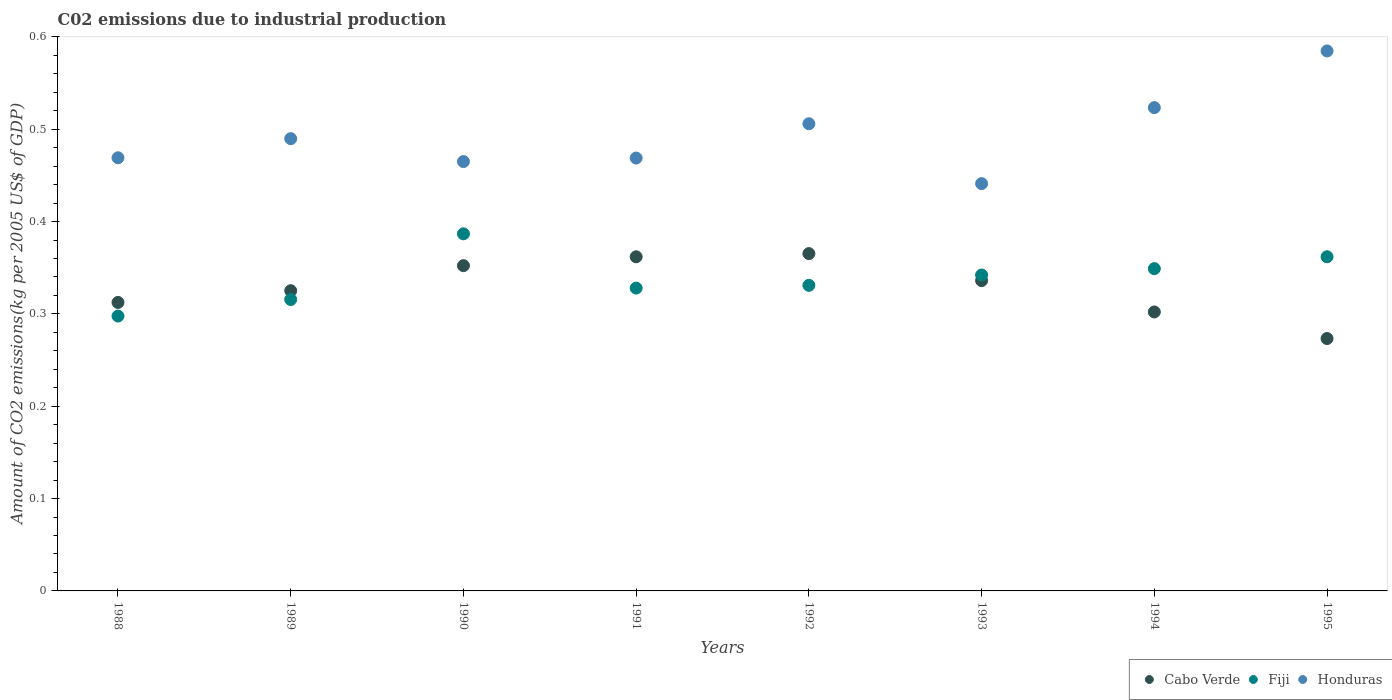What is the amount of CO2 emitted due to industrial production in Fiji in 1988?
Offer a very short reply. 0.3. Across all years, what is the maximum amount of CO2 emitted due to industrial production in Honduras?
Provide a succinct answer. 0.58. Across all years, what is the minimum amount of CO2 emitted due to industrial production in Cabo Verde?
Provide a short and direct response. 0.27. In which year was the amount of CO2 emitted due to industrial production in Honduras maximum?
Offer a very short reply. 1995. In which year was the amount of CO2 emitted due to industrial production in Fiji minimum?
Offer a terse response. 1988. What is the total amount of CO2 emitted due to industrial production in Fiji in the graph?
Your answer should be compact. 2.71. What is the difference between the amount of CO2 emitted due to industrial production in Cabo Verde in 1990 and that in 1993?
Offer a terse response. 0.02. What is the difference between the amount of CO2 emitted due to industrial production in Fiji in 1994 and the amount of CO2 emitted due to industrial production in Honduras in 1989?
Ensure brevity in your answer.  -0.14. What is the average amount of CO2 emitted due to industrial production in Cabo Verde per year?
Ensure brevity in your answer.  0.33. In the year 1994, what is the difference between the amount of CO2 emitted due to industrial production in Cabo Verde and amount of CO2 emitted due to industrial production in Honduras?
Give a very brief answer. -0.22. What is the ratio of the amount of CO2 emitted due to industrial production in Cabo Verde in 1988 to that in 1992?
Ensure brevity in your answer.  0.86. Is the difference between the amount of CO2 emitted due to industrial production in Cabo Verde in 1990 and 1991 greater than the difference between the amount of CO2 emitted due to industrial production in Honduras in 1990 and 1991?
Your response must be concise. No. What is the difference between the highest and the second highest amount of CO2 emitted due to industrial production in Cabo Verde?
Ensure brevity in your answer.  0. What is the difference between the highest and the lowest amount of CO2 emitted due to industrial production in Honduras?
Your answer should be compact. 0.14. In how many years, is the amount of CO2 emitted due to industrial production in Cabo Verde greater than the average amount of CO2 emitted due to industrial production in Cabo Verde taken over all years?
Your response must be concise. 4. Is the sum of the amount of CO2 emitted due to industrial production in Honduras in 1990 and 1991 greater than the maximum amount of CO2 emitted due to industrial production in Cabo Verde across all years?
Your response must be concise. Yes. Is it the case that in every year, the sum of the amount of CO2 emitted due to industrial production in Cabo Verde and amount of CO2 emitted due to industrial production in Fiji  is greater than the amount of CO2 emitted due to industrial production in Honduras?
Provide a succinct answer. Yes. Does the amount of CO2 emitted due to industrial production in Cabo Verde monotonically increase over the years?
Offer a very short reply. No. Is the amount of CO2 emitted due to industrial production in Fiji strictly greater than the amount of CO2 emitted due to industrial production in Cabo Verde over the years?
Offer a very short reply. No. Is the amount of CO2 emitted due to industrial production in Honduras strictly less than the amount of CO2 emitted due to industrial production in Cabo Verde over the years?
Provide a short and direct response. No. How many dotlines are there?
Your answer should be very brief. 3. How many years are there in the graph?
Your answer should be compact. 8. What is the difference between two consecutive major ticks on the Y-axis?
Give a very brief answer. 0.1. Are the values on the major ticks of Y-axis written in scientific E-notation?
Make the answer very short. No. Does the graph contain any zero values?
Offer a terse response. No. Where does the legend appear in the graph?
Give a very brief answer. Bottom right. How many legend labels are there?
Make the answer very short. 3. How are the legend labels stacked?
Provide a short and direct response. Horizontal. What is the title of the graph?
Offer a very short reply. C02 emissions due to industrial production. Does "Senegal" appear as one of the legend labels in the graph?
Make the answer very short. No. What is the label or title of the X-axis?
Provide a short and direct response. Years. What is the label or title of the Y-axis?
Provide a short and direct response. Amount of CO2 emissions(kg per 2005 US$ of GDP). What is the Amount of CO2 emissions(kg per 2005 US$ of GDP) of Cabo Verde in 1988?
Make the answer very short. 0.31. What is the Amount of CO2 emissions(kg per 2005 US$ of GDP) in Fiji in 1988?
Make the answer very short. 0.3. What is the Amount of CO2 emissions(kg per 2005 US$ of GDP) in Honduras in 1988?
Your answer should be very brief. 0.47. What is the Amount of CO2 emissions(kg per 2005 US$ of GDP) in Cabo Verde in 1989?
Keep it short and to the point. 0.33. What is the Amount of CO2 emissions(kg per 2005 US$ of GDP) in Fiji in 1989?
Give a very brief answer. 0.32. What is the Amount of CO2 emissions(kg per 2005 US$ of GDP) of Honduras in 1989?
Your answer should be very brief. 0.49. What is the Amount of CO2 emissions(kg per 2005 US$ of GDP) of Cabo Verde in 1990?
Offer a terse response. 0.35. What is the Amount of CO2 emissions(kg per 2005 US$ of GDP) of Fiji in 1990?
Keep it short and to the point. 0.39. What is the Amount of CO2 emissions(kg per 2005 US$ of GDP) of Honduras in 1990?
Offer a terse response. 0.46. What is the Amount of CO2 emissions(kg per 2005 US$ of GDP) of Cabo Verde in 1991?
Your answer should be compact. 0.36. What is the Amount of CO2 emissions(kg per 2005 US$ of GDP) in Fiji in 1991?
Make the answer very short. 0.33. What is the Amount of CO2 emissions(kg per 2005 US$ of GDP) in Honduras in 1991?
Your answer should be compact. 0.47. What is the Amount of CO2 emissions(kg per 2005 US$ of GDP) in Cabo Verde in 1992?
Keep it short and to the point. 0.37. What is the Amount of CO2 emissions(kg per 2005 US$ of GDP) of Fiji in 1992?
Provide a succinct answer. 0.33. What is the Amount of CO2 emissions(kg per 2005 US$ of GDP) in Honduras in 1992?
Your answer should be compact. 0.51. What is the Amount of CO2 emissions(kg per 2005 US$ of GDP) of Cabo Verde in 1993?
Provide a succinct answer. 0.34. What is the Amount of CO2 emissions(kg per 2005 US$ of GDP) of Fiji in 1993?
Ensure brevity in your answer.  0.34. What is the Amount of CO2 emissions(kg per 2005 US$ of GDP) of Honduras in 1993?
Ensure brevity in your answer.  0.44. What is the Amount of CO2 emissions(kg per 2005 US$ of GDP) of Cabo Verde in 1994?
Your answer should be very brief. 0.3. What is the Amount of CO2 emissions(kg per 2005 US$ of GDP) in Fiji in 1994?
Your answer should be very brief. 0.35. What is the Amount of CO2 emissions(kg per 2005 US$ of GDP) of Honduras in 1994?
Provide a succinct answer. 0.52. What is the Amount of CO2 emissions(kg per 2005 US$ of GDP) in Cabo Verde in 1995?
Ensure brevity in your answer.  0.27. What is the Amount of CO2 emissions(kg per 2005 US$ of GDP) of Fiji in 1995?
Provide a succinct answer. 0.36. What is the Amount of CO2 emissions(kg per 2005 US$ of GDP) of Honduras in 1995?
Provide a short and direct response. 0.58. Across all years, what is the maximum Amount of CO2 emissions(kg per 2005 US$ of GDP) in Cabo Verde?
Keep it short and to the point. 0.37. Across all years, what is the maximum Amount of CO2 emissions(kg per 2005 US$ of GDP) in Fiji?
Your answer should be compact. 0.39. Across all years, what is the maximum Amount of CO2 emissions(kg per 2005 US$ of GDP) of Honduras?
Make the answer very short. 0.58. Across all years, what is the minimum Amount of CO2 emissions(kg per 2005 US$ of GDP) of Cabo Verde?
Your response must be concise. 0.27. Across all years, what is the minimum Amount of CO2 emissions(kg per 2005 US$ of GDP) in Fiji?
Your response must be concise. 0.3. Across all years, what is the minimum Amount of CO2 emissions(kg per 2005 US$ of GDP) of Honduras?
Offer a very short reply. 0.44. What is the total Amount of CO2 emissions(kg per 2005 US$ of GDP) in Cabo Verde in the graph?
Give a very brief answer. 2.63. What is the total Amount of CO2 emissions(kg per 2005 US$ of GDP) in Fiji in the graph?
Make the answer very short. 2.71. What is the total Amount of CO2 emissions(kg per 2005 US$ of GDP) in Honduras in the graph?
Provide a succinct answer. 3.95. What is the difference between the Amount of CO2 emissions(kg per 2005 US$ of GDP) in Cabo Verde in 1988 and that in 1989?
Your answer should be compact. -0.01. What is the difference between the Amount of CO2 emissions(kg per 2005 US$ of GDP) in Fiji in 1988 and that in 1989?
Offer a very short reply. -0.02. What is the difference between the Amount of CO2 emissions(kg per 2005 US$ of GDP) in Honduras in 1988 and that in 1989?
Offer a very short reply. -0.02. What is the difference between the Amount of CO2 emissions(kg per 2005 US$ of GDP) of Cabo Verde in 1988 and that in 1990?
Offer a very short reply. -0.04. What is the difference between the Amount of CO2 emissions(kg per 2005 US$ of GDP) in Fiji in 1988 and that in 1990?
Offer a very short reply. -0.09. What is the difference between the Amount of CO2 emissions(kg per 2005 US$ of GDP) in Honduras in 1988 and that in 1990?
Give a very brief answer. 0. What is the difference between the Amount of CO2 emissions(kg per 2005 US$ of GDP) of Cabo Verde in 1988 and that in 1991?
Provide a succinct answer. -0.05. What is the difference between the Amount of CO2 emissions(kg per 2005 US$ of GDP) in Fiji in 1988 and that in 1991?
Your answer should be very brief. -0.03. What is the difference between the Amount of CO2 emissions(kg per 2005 US$ of GDP) of Honduras in 1988 and that in 1991?
Your answer should be compact. 0. What is the difference between the Amount of CO2 emissions(kg per 2005 US$ of GDP) in Cabo Verde in 1988 and that in 1992?
Ensure brevity in your answer.  -0.05. What is the difference between the Amount of CO2 emissions(kg per 2005 US$ of GDP) of Fiji in 1988 and that in 1992?
Provide a succinct answer. -0.03. What is the difference between the Amount of CO2 emissions(kg per 2005 US$ of GDP) in Honduras in 1988 and that in 1992?
Provide a succinct answer. -0.04. What is the difference between the Amount of CO2 emissions(kg per 2005 US$ of GDP) of Cabo Verde in 1988 and that in 1993?
Offer a terse response. -0.02. What is the difference between the Amount of CO2 emissions(kg per 2005 US$ of GDP) of Fiji in 1988 and that in 1993?
Your answer should be very brief. -0.04. What is the difference between the Amount of CO2 emissions(kg per 2005 US$ of GDP) in Honduras in 1988 and that in 1993?
Your answer should be very brief. 0.03. What is the difference between the Amount of CO2 emissions(kg per 2005 US$ of GDP) of Cabo Verde in 1988 and that in 1994?
Provide a succinct answer. 0.01. What is the difference between the Amount of CO2 emissions(kg per 2005 US$ of GDP) of Fiji in 1988 and that in 1994?
Your response must be concise. -0.05. What is the difference between the Amount of CO2 emissions(kg per 2005 US$ of GDP) in Honduras in 1988 and that in 1994?
Make the answer very short. -0.05. What is the difference between the Amount of CO2 emissions(kg per 2005 US$ of GDP) of Cabo Verde in 1988 and that in 1995?
Your answer should be very brief. 0.04. What is the difference between the Amount of CO2 emissions(kg per 2005 US$ of GDP) of Fiji in 1988 and that in 1995?
Your response must be concise. -0.06. What is the difference between the Amount of CO2 emissions(kg per 2005 US$ of GDP) of Honduras in 1988 and that in 1995?
Provide a succinct answer. -0.12. What is the difference between the Amount of CO2 emissions(kg per 2005 US$ of GDP) in Cabo Verde in 1989 and that in 1990?
Keep it short and to the point. -0.03. What is the difference between the Amount of CO2 emissions(kg per 2005 US$ of GDP) in Fiji in 1989 and that in 1990?
Ensure brevity in your answer.  -0.07. What is the difference between the Amount of CO2 emissions(kg per 2005 US$ of GDP) in Honduras in 1989 and that in 1990?
Provide a short and direct response. 0.02. What is the difference between the Amount of CO2 emissions(kg per 2005 US$ of GDP) in Cabo Verde in 1989 and that in 1991?
Your answer should be very brief. -0.04. What is the difference between the Amount of CO2 emissions(kg per 2005 US$ of GDP) in Fiji in 1989 and that in 1991?
Ensure brevity in your answer.  -0.01. What is the difference between the Amount of CO2 emissions(kg per 2005 US$ of GDP) of Honduras in 1989 and that in 1991?
Offer a very short reply. 0.02. What is the difference between the Amount of CO2 emissions(kg per 2005 US$ of GDP) in Cabo Verde in 1989 and that in 1992?
Your answer should be very brief. -0.04. What is the difference between the Amount of CO2 emissions(kg per 2005 US$ of GDP) in Fiji in 1989 and that in 1992?
Make the answer very short. -0.02. What is the difference between the Amount of CO2 emissions(kg per 2005 US$ of GDP) of Honduras in 1989 and that in 1992?
Make the answer very short. -0.02. What is the difference between the Amount of CO2 emissions(kg per 2005 US$ of GDP) in Cabo Verde in 1989 and that in 1993?
Give a very brief answer. -0.01. What is the difference between the Amount of CO2 emissions(kg per 2005 US$ of GDP) in Fiji in 1989 and that in 1993?
Offer a very short reply. -0.03. What is the difference between the Amount of CO2 emissions(kg per 2005 US$ of GDP) in Honduras in 1989 and that in 1993?
Your answer should be very brief. 0.05. What is the difference between the Amount of CO2 emissions(kg per 2005 US$ of GDP) in Cabo Verde in 1989 and that in 1994?
Your response must be concise. 0.02. What is the difference between the Amount of CO2 emissions(kg per 2005 US$ of GDP) in Fiji in 1989 and that in 1994?
Your answer should be compact. -0.03. What is the difference between the Amount of CO2 emissions(kg per 2005 US$ of GDP) in Honduras in 1989 and that in 1994?
Your response must be concise. -0.03. What is the difference between the Amount of CO2 emissions(kg per 2005 US$ of GDP) in Cabo Verde in 1989 and that in 1995?
Make the answer very short. 0.05. What is the difference between the Amount of CO2 emissions(kg per 2005 US$ of GDP) of Fiji in 1989 and that in 1995?
Make the answer very short. -0.05. What is the difference between the Amount of CO2 emissions(kg per 2005 US$ of GDP) in Honduras in 1989 and that in 1995?
Offer a very short reply. -0.1. What is the difference between the Amount of CO2 emissions(kg per 2005 US$ of GDP) of Cabo Verde in 1990 and that in 1991?
Provide a succinct answer. -0.01. What is the difference between the Amount of CO2 emissions(kg per 2005 US$ of GDP) in Fiji in 1990 and that in 1991?
Provide a succinct answer. 0.06. What is the difference between the Amount of CO2 emissions(kg per 2005 US$ of GDP) of Honduras in 1990 and that in 1991?
Provide a short and direct response. -0. What is the difference between the Amount of CO2 emissions(kg per 2005 US$ of GDP) in Cabo Verde in 1990 and that in 1992?
Provide a succinct answer. -0.01. What is the difference between the Amount of CO2 emissions(kg per 2005 US$ of GDP) of Fiji in 1990 and that in 1992?
Offer a terse response. 0.06. What is the difference between the Amount of CO2 emissions(kg per 2005 US$ of GDP) of Honduras in 1990 and that in 1992?
Provide a short and direct response. -0.04. What is the difference between the Amount of CO2 emissions(kg per 2005 US$ of GDP) of Cabo Verde in 1990 and that in 1993?
Provide a succinct answer. 0.02. What is the difference between the Amount of CO2 emissions(kg per 2005 US$ of GDP) in Fiji in 1990 and that in 1993?
Offer a very short reply. 0.04. What is the difference between the Amount of CO2 emissions(kg per 2005 US$ of GDP) in Honduras in 1990 and that in 1993?
Keep it short and to the point. 0.02. What is the difference between the Amount of CO2 emissions(kg per 2005 US$ of GDP) in Cabo Verde in 1990 and that in 1994?
Your answer should be compact. 0.05. What is the difference between the Amount of CO2 emissions(kg per 2005 US$ of GDP) of Fiji in 1990 and that in 1994?
Provide a short and direct response. 0.04. What is the difference between the Amount of CO2 emissions(kg per 2005 US$ of GDP) of Honduras in 1990 and that in 1994?
Provide a short and direct response. -0.06. What is the difference between the Amount of CO2 emissions(kg per 2005 US$ of GDP) of Cabo Verde in 1990 and that in 1995?
Your answer should be very brief. 0.08. What is the difference between the Amount of CO2 emissions(kg per 2005 US$ of GDP) in Fiji in 1990 and that in 1995?
Ensure brevity in your answer.  0.02. What is the difference between the Amount of CO2 emissions(kg per 2005 US$ of GDP) of Honduras in 1990 and that in 1995?
Offer a very short reply. -0.12. What is the difference between the Amount of CO2 emissions(kg per 2005 US$ of GDP) of Cabo Verde in 1991 and that in 1992?
Give a very brief answer. -0. What is the difference between the Amount of CO2 emissions(kg per 2005 US$ of GDP) in Fiji in 1991 and that in 1992?
Your answer should be very brief. -0. What is the difference between the Amount of CO2 emissions(kg per 2005 US$ of GDP) in Honduras in 1991 and that in 1992?
Provide a succinct answer. -0.04. What is the difference between the Amount of CO2 emissions(kg per 2005 US$ of GDP) of Cabo Verde in 1991 and that in 1993?
Your response must be concise. 0.03. What is the difference between the Amount of CO2 emissions(kg per 2005 US$ of GDP) in Fiji in 1991 and that in 1993?
Your answer should be compact. -0.01. What is the difference between the Amount of CO2 emissions(kg per 2005 US$ of GDP) of Honduras in 1991 and that in 1993?
Your answer should be compact. 0.03. What is the difference between the Amount of CO2 emissions(kg per 2005 US$ of GDP) of Cabo Verde in 1991 and that in 1994?
Give a very brief answer. 0.06. What is the difference between the Amount of CO2 emissions(kg per 2005 US$ of GDP) of Fiji in 1991 and that in 1994?
Keep it short and to the point. -0.02. What is the difference between the Amount of CO2 emissions(kg per 2005 US$ of GDP) in Honduras in 1991 and that in 1994?
Provide a succinct answer. -0.05. What is the difference between the Amount of CO2 emissions(kg per 2005 US$ of GDP) in Cabo Verde in 1991 and that in 1995?
Offer a very short reply. 0.09. What is the difference between the Amount of CO2 emissions(kg per 2005 US$ of GDP) in Fiji in 1991 and that in 1995?
Provide a succinct answer. -0.03. What is the difference between the Amount of CO2 emissions(kg per 2005 US$ of GDP) of Honduras in 1991 and that in 1995?
Your answer should be very brief. -0.12. What is the difference between the Amount of CO2 emissions(kg per 2005 US$ of GDP) in Cabo Verde in 1992 and that in 1993?
Ensure brevity in your answer.  0.03. What is the difference between the Amount of CO2 emissions(kg per 2005 US$ of GDP) of Fiji in 1992 and that in 1993?
Provide a succinct answer. -0.01. What is the difference between the Amount of CO2 emissions(kg per 2005 US$ of GDP) of Honduras in 1992 and that in 1993?
Make the answer very short. 0.06. What is the difference between the Amount of CO2 emissions(kg per 2005 US$ of GDP) of Cabo Verde in 1992 and that in 1994?
Your answer should be compact. 0.06. What is the difference between the Amount of CO2 emissions(kg per 2005 US$ of GDP) of Fiji in 1992 and that in 1994?
Ensure brevity in your answer.  -0.02. What is the difference between the Amount of CO2 emissions(kg per 2005 US$ of GDP) in Honduras in 1992 and that in 1994?
Ensure brevity in your answer.  -0.02. What is the difference between the Amount of CO2 emissions(kg per 2005 US$ of GDP) in Cabo Verde in 1992 and that in 1995?
Your response must be concise. 0.09. What is the difference between the Amount of CO2 emissions(kg per 2005 US$ of GDP) of Fiji in 1992 and that in 1995?
Make the answer very short. -0.03. What is the difference between the Amount of CO2 emissions(kg per 2005 US$ of GDP) in Honduras in 1992 and that in 1995?
Your answer should be very brief. -0.08. What is the difference between the Amount of CO2 emissions(kg per 2005 US$ of GDP) in Cabo Verde in 1993 and that in 1994?
Make the answer very short. 0.03. What is the difference between the Amount of CO2 emissions(kg per 2005 US$ of GDP) of Fiji in 1993 and that in 1994?
Your answer should be very brief. -0.01. What is the difference between the Amount of CO2 emissions(kg per 2005 US$ of GDP) in Honduras in 1993 and that in 1994?
Your answer should be very brief. -0.08. What is the difference between the Amount of CO2 emissions(kg per 2005 US$ of GDP) of Cabo Verde in 1993 and that in 1995?
Your response must be concise. 0.06. What is the difference between the Amount of CO2 emissions(kg per 2005 US$ of GDP) of Fiji in 1993 and that in 1995?
Make the answer very short. -0.02. What is the difference between the Amount of CO2 emissions(kg per 2005 US$ of GDP) in Honduras in 1993 and that in 1995?
Your response must be concise. -0.14. What is the difference between the Amount of CO2 emissions(kg per 2005 US$ of GDP) of Cabo Verde in 1994 and that in 1995?
Make the answer very short. 0.03. What is the difference between the Amount of CO2 emissions(kg per 2005 US$ of GDP) of Fiji in 1994 and that in 1995?
Make the answer very short. -0.01. What is the difference between the Amount of CO2 emissions(kg per 2005 US$ of GDP) in Honduras in 1994 and that in 1995?
Keep it short and to the point. -0.06. What is the difference between the Amount of CO2 emissions(kg per 2005 US$ of GDP) in Cabo Verde in 1988 and the Amount of CO2 emissions(kg per 2005 US$ of GDP) in Fiji in 1989?
Your answer should be very brief. -0. What is the difference between the Amount of CO2 emissions(kg per 2005 US$ of GDP) of Cabo Verde in 1988 and the Amount of CO2 emissions(kg per 2005 US$ of GDP) of Honduras in 1989?
Provide a succinct answer. -0.18. What is the difference between the Amount of CO2 emissions(kg per 2005 US$ of GDP) in Fiji in 1988 and the Amount of CO2 emissions(kg per 2005 US$ of GDP) in Honduras in 1989?
Make the answer very short. -0.19. What is the difference between the Amount of CO2 emissions(kg per 2005 US$ of GDP) in Cabo Verde in 1988 and the Amount of CO2 emissions(kg per 2005 US$ of GDP) in Fiji in 1990?
Make the answer very short. -0.07. What is the difference between the Amount of CO2 emissions(kg per 2005 US$ of GDP) in Cabo Verde in 1988 and the Amount of CO2 emissions(kg per 2005 US$ of GDP) in Honduras in 1990?
Keep it short and to the point. -0.15. What is the difference between the Amount of CO2 emissions(kg per 2005 US$ of GDP) of Fiji in 1988 and the Amount of CO2 emissions(kg per 2005 US$ of GDP) of Honduras in 1990?
Your answer should be very brief. -0.17. What is the difference between the Amount of CO2 emissions(kg per 2005 US$ of GDP) of Cabo Verde in 1988 and the Amount of CO2 emissions(kg per 2005 US$ of GDP) of Fiji in 1991?
Provide a succinct answer. -0.02. What is the difference between the Amount of CO2 emissions(kg per 2005 US$ of GDP) in Cabo Verde in 1988 and the Amount of CO2 emissions(kg per 2005 US$ of GDP) in Honduras in 1991?
Keep it short and to the point. -0.16. What is the difference between the Amount of CO2 emissions(kg per 2005 US$ of GDP) in Fiji in 1988 and the Amount of CO2 emissions(kg per 2005 US$ of GDP) in Honduras in 1991?
Your answer should be compact. -0.17. What is the difference between the Amount of CO2 emissions(kg per 2005 US$ of GDP) of Cabo Verde in 1988 and the Amount of CO2 emissions(kg per 2005 US$ of GDP) of Fiji in 1992?
Your answer should be compact. -0.02. What is the difference between the Amount of CO2 emissions(kg per 2005 US$ of GDP) in Cabo Verde in 1988 and the Amount of CO2 emissions(kg per 2005 US$ of GDP) in Honduras in 1992?
Your response must be concise. -0.19. What is the difference between the Amount of CO2 emissions(kg per 2005 US$ of GDP) in Fiji in 1988 and the Amount of CO2 emissions(kg per 2005 US$ of GDP) in Honduras in 1992?
Provide a succinct answer. -0.21. What is the difference between the Amount of CO2 emissions(kg per 2005 US$ of GDP) in Cabo Verde in 1988 and the Amount of CO2 emissions(kg per 2005 US$ of GDP) in Fiji in 1993?
Ensure brevity in your answer.  -0.03. What is the difference between the Amount of CO2 emissions(kg per 2005 US$ of GDP) of Cabo Verde in 1988 and the Amount of CO2 emissions(kg per 2005 US$ of GDP) of Honduras in 1993?
Give a very brief answer. -0.13. What is the difference between the Amount of CO2 emissions(kg per 2005 US$ of GDP) of Fiji in 1988 and the Amount of CO2 emissions(kg per 2005 US$ of GDP) of Honduras in 1993?
Offer a very short reply. -0.14. What is the difference between the Amount of CO2 emissions(kg per 2005 US$ of GDP) in Cabo Verde in 1988 and the Amount of CO2 emissions(kg per 2005 US$ of GDP) in Fiji in 1994?
Ensure brevity in your answer.  -0.04. What is the difference between the Amount of CO2 emissions(kg per 2005 US$ of GDP) in Cabo Verde in 1988 and the Amount of CO2 emissions(kg per 2005 US$ of GDP) in Honduras in 1994?
Provide a short and direct response. -0.21. What is the difference between the Amount of CO2 emissions(kg per 2005 US$ of GDP) in Fiji in 1988 and the Amount of CO2 emissions(kg per 2005 US$ of GDP) in Honduras in 1994?
Provide a short and direct response. -0.23. What is the difference between the Amount of CO2 emissions(kg per 2005 US$ of GDP) of Cabo Verde in 1988 and the Amount of CO2 emissions(kg per 2005 US$ of GDP) of Fiji in 1995?
Ensure brevity in your answer.  -0.05. What is the difference between the Amount of CO2 emissions(kg per 2005 US$ of GDP) of Cabo Verde in 1988 and the Amount of CO2 emissions(kg per 2005 US$ of GDP) of Honduras in 1995?
Ensure brevity in your answer.  -0.27. What is the difference between the Amount of CO2 emissions(kg per 2005 US$ of GDP) of Fiji in 1988 and the Amount of CO2 emissions(kg per 2005 US$ of GDP) of Honduras in 1995?
Keep it short and to the point. -0.29. What is the difference between the Amount of CO2 emissions(kg per 2005 US$ of GDP) of Cabo Verde in 1989 and the Amount of CO2 emissions(kg per 2005 US$ of GDP) of Fiji in 1990?
Offer a very short reply. -0.06. What is the difference between the Amount of CO2 emissions(kg per 2005 US$ of GDP) in Cabo Verde in 1989 and the Amount of CO2 emissions(kg per 2005 US$ of GDP) in Honduras in 1990?
Ensure brevity in your answer.  -0.14. What is the difference between the Amount of CO2 emissions(kg per 2005 US$ of GDP) in Fiji in 1989 and the Amount of CO2 emissions(kg per 2005 US$ of GDP) in Honduras in 1990?
Offer a very short reply. -0.15. What is the difference between the Amount of CO2 emissions(kg per 2005 US$ of GDP) of Cabo Verde in 1989 and the Amount of CO2 emissions(kg per 2005 US$ of GDP) of Fiji in 1991?
Your answer should be compact. -0. What is the difference between the Amount of CO2 emissions(kg per 2005 US$ of GDP) of Cabo Verde in 1989 and the Amount of CO2 emissions(kg per 2005 US$ of GDP) of Honduras in 1991?
Make the answer very short. -0.14. What is the difference between the Amount of CO2 emissions(kg per 2005 US$ of GDP) in Fiji in 1989 and the Amount of CO2 emissions(kg per 2005 US$ of GDP) in Honduras in 1991?
Ensure brevity in your answer.  -0.15. What is the difference between the Amount of CO2 emissions(kg per 2005 US$ of GDP) in Cabo Verde in 1989 and the Amount of CO2 emissions(kg per 2005 US$ of GDP) in Fiji in 1992?
Offer a very short reply. -0.01. What is the difference between the Amount of CO2 emissions(kg per 2005 US$ of GDP) in Cabo Verde in 1989 and the Amount of CO2 emissions(kg per 2005 US$ of GDP) in Honduras in 1992?
Give a very brief answer. -0.18. What is the difference between the Amount of CO2 emissions(kg per 2005 US$ of GDP) in Fiji in 1989 and the Amount of CO2 emissions(kg per 2005 US$ of GDP) in Honduras in 1992?
Your answer should be compact. -0.19. What is the difference between the Amount of CO2 emissions(kg per 2005 US$ of GDP) in Cabo Verde in 1989 and the Amount of CO2 emissions(kg per 2005 US$ of GDP) in Fiji in 1993?
Offer a terse response. -0.02. What is the difference between the Amount of CO2 emissions(kg per 2005 US$ of GDP) of Cabo Verde in 1989 and the Amount of CO2 emissions(kg per 2005 US$ of GDP) of Honduras in 1993?
Your answer should be very brief. -0.12. What is the difference between the Amount of CO2 emissions(kg per 2005 US$ of GDP) in Fiji in 1989 and the Amount of CO2 emissions(kg per 2005 US$ of GDP) in Honduras in 1993?
Your response must be concise. -0.13. What is the difference between the Amount of CO2 emissions(kg per 2005 US$ of GDP) of Cabo Verde in 1989 and the Amount of CO2 emissions(kg per 2005 US$ of GDP) of Fiji in 1994?
Provide a succinct answer. -0.02. What is the difference between the Amount of CO2 emissions(kg per 2005 US$ of GDP) in Cabo Verde in 1989 and the Amount of CO2 emissions(kg per 2005 US$ of GDP) in Honduras in 1994?
Keep it short and to the point. -0.2. What is the difference between the Amount of CO2 emissions(kg per 2005 US$ of GDP) in Fiji in 1989 and the Amount of CO2 emissions(kg per 2005 US$ of GDP) in Honduras in 1994?
Keep it short and to the point. -0.21. What is the difference between the Amount of CO2 emissions(kg per 2005 US$ of GDP) of Cabo Verde in 1989 and the Amount of CO2 emissions(kg per 2005 US$ of GDP) of Fiji in 1995?
Your answer should be very brief. -0.04. What is the difference between the Amount of CO2 emissions(kg per 2005 US$ of GDP) in Cabo Verde in 1989 and the Amount of CO2 emissions(kg per 2005 US$ of GDP) in Honduras in 1995?
Make the answer very short. -0.26. What is the difference between the Amount of CO2 emissions(kg per 2005 US$ of GDP) of Fiji in 1989 and the Amount of CO2 emissions(kg per 2005 US$ of GDP) of Honduras in 1995?
Keep it short and to the point. -0.27. What is the difference between the Amount of CO2 emissions(kg per 2005 US$ of GDP) of Cabo Verde in 1990 and the Amount of CO2 emissions(kg per 2005 US$ of GDP) of Fiji in 1991?
Offer a terse response. 0.02. What is the difference between the Amount of CO2 emissions(kg per 2005 US$ of GDP) of Cabo Verde in 1990 and the Amount of CO2 emissions(kg per 2005 US$ of GDP) of Honduras in 1991?
Your answer should be very brief. -0.12. What is the difference between the Amount of CO2 emissions(kg per 2005 US$ of GDP) of Fiji in 1990 and the Amount of CO2 emissions(kg per 2005 US$ of GDP) of Honduras in 1991?
Offer a very short reply. -0.08. What is the difference between the Amount of CO2 emissions(kg per 2005 US$ of GDP) in Cabo Verde in 1990 and the Amount of CO2 emissions(kg per 2005 US$ of GDP) in Fiji in 1992?
Your answer should be very brief. 0.02. What is the difference between the Amount of CO2 emissions(kg per 2005 US$ of GDP) in Cabo Verde in 1990 and the Amount of CO2 emissions(kg per 2005 US$ of GDP) in Honduras in 1992?
Offer a terse response. -0.15. What is the difference between the Amount of CO2 emissions(kg per 2005 US$ of GDP) of Fiji in 1990 and the Amount of CO2 emissions(kg per 2005 US$ of GDP) of Honduras in 1992?
Make the answer very short. -0.12. What is the difference between the Amount of CO2 emissions(kg per 2005 US$ of GDP) of Cabo Verde in 1990 and the Amount of CO2 emissions(kg per 2005 US$ of GDP) of Fiji in 1993?
Ensure brevity in your answer.  0.01. What is the difference between the Amount of CO2 emissions(kg per 2005 US$ of GDP) in Cabo Verde in 1990 and the Amount of CO2 emissions(kg per 2005 US$ of GDP) in Honduras in 1993?
Make the answer very short. -0.09. What is the difference between the Amount of CO2 emissions(kg per 2005 US$ of GDP) in Fiji in 1990 and the Amount of CO2 emissions(kg per 2005 US$ of GDP) in Honduras in 1993?
Your answer should be compact. -0.05. What is the difference between the Amount of CO2 emissions(kg per 2005 US$ of GDP) in Cabo Verde in 1990 and the Amount of CO2 emissions(kg per 2005 US$ of GDP) in Fiji in 1994?
Make the answer very short. 0. What is the difference between the Amount of CO2 emissions(kg per 2005 US$ of GDP) of Cabo Verde in 1990 and the Amount of CO2 emissions(kg per 2005 US$ of GDP) of Honduras in 1994?
Offer a terse response. -0.17. What is the difference between the Amount of CO2 emissions(kg per 2005 US$ of GDP) of Fiji in 1990 and the Amount of CO2 emissions(kg per 2005 US$ of GDP) of Honduras in 1994?
Offer a very short reply. -0.14. What is the difference between the Amount of CO2 emissions(kg per 2005 US$ of GDP) in Cabo Verde in 1990 and the Amount of CO2 emissions(kg per 2005 US$ of GDP) in Fiji in 1995?
Offer a very short reply. -0.01. What is the difference between the Amount of CO2 emissions(kg per 2005 US$ of GDP) in Cabo Verde in 1990 and the Amount of CO2 emissions(kg per 2005 US$ of GDP) in Honduras in 1995?
Make the answer very short. -0.23. What is the difference between the Amount of CO2 emissions(kg per 2005 US$ of GDP) of Fiji in 1990 and the Amount of CO2 emissions(kg per 2005 US$ of GDP) of Honduras in 1995?
Ensure brevity in your answer.  -0.2. What is the difference between the Amount of CO2 emissions(kg per 2005 US$ of GDP) of Cabo Verde in 1991 and the Amount of CO2 emissions(kg per 2005 US$ of GDP) of Fiji in 1992?
Your answer should be very brief. 0.03. What is the difference between the Amount of CO2 emissions(kg per 2005 US$ of GDP) of Cabo Verde in 1991 and the Amount of CO2 emissions(kg per 2005 US$ of GDP) of Honduras in 1992?
Your response must be concise. -0.14. What is the difference between the Amount of CO2 emissions(kg per 2005 US$ of GDP) of Fiji in 1991 and the Amount of CO2 emissions(kg per 2005 US$ of GDP) of Honduras in 1992?
Ensure brevity in your answer.  -0.18. What is the difference between the Amount of CO2 emissions(kg per 2005 US$ of GDP) of Cabo Verde in 1991 and the Amount of CO2 emissions(kg per 2005 US$ of GDP) of Fiji in 1993?
Your answer should be compact. 0.02. What is the difference between the Amount of CO2 emissions(kg per 2005 US$ of GDP) in Cabo Verde in 1991 and the Amount of CO2 emissions(kg per 2005 US$ of GDP) in Honduras in 1993?
Make the answer very short. -0.08. What is the difference between the Amount of CO2 emissions(kg per 2005 US$ of GDP) in Fiji in 1991 and the Amount of CO2 emissions(kg per 2005 US$ of GDP) in Honduras in 1993?
Make the answer very short. -0.11. What is the difference between the Amount of CO2 emissions(kg per 2005 US$ of GDP) in Cabo Verde in 1991 and the Amount of CO2 emissions(kg per 2005 US$ of GDP) in Fiji in 1994?
Make the answer very short. 0.01. What is the difference between the Amount of CO2 emissions(kg per 2005 US$ of GDP) in Cabo Verde in 1991 and the Amount of CO2 emissions(kg per 2005 US$ of GDP) in Honduras in 1994?
Keep it short and to the point. -0.16. What is the difference between the Amount of CO2 emissions(kg per 2005 US$ of GDP) in Fiji in 1991 and the Amount of CO2 emissions(kg per 2005 US$ of GDP) in Honduras in 1994?
Keep it short and to the point. -0.2. What is the difference between the Amount of CO2 emissions(kg per 2005 US$ of GDP) of Cabo Verde in 1991 and the Amount of CO2 emissions(kg per 2005 US$ of GDP) of Fiji in 1995?
Offer a very short reply. -0. What is the difference between the Amount of CO2 emissions(kg per 2005 US$ of GDP) in Cabo Verde in 1991 and the Amount of CO2 emissions(kg per 2005 US$ of GDP) in Honduras in 1995?
Give a very brief answer. -0.22. What is the difference between the Amount of CO2 emissions(kg per 2005 US$ of GDP) of Fiji in 1991 and the Amount of CO2 emissions(kg per 2005 US$ of GDP) of Honduras in 1995?
Give a very brief answer. -0.26. What is the difference between the Amount of CO2 emissions(kg per 2005 US$ of GDP) in Cabo Verde in 1992 and the Amount of CO2 emissions(kg per 2005 US$ of GDP) in Fiji in 1993?
Your answer should be very brief. 0.02. What is the difference between the Amount of CO2 emissions(kg per 2005 US$ of GDP) in Cabo Verde in 1992 and the Amount of CO2 emissions(kg per 2005 US$ of GDP) in Honduras in 1993?
Make the answer very short. -0.08. What is the difference between the Amount of CO2 emissions(kg per 2005 US$ of GDP) in Fiji in 1992 and the Amount of CO2 emissions(kg per 2005 US$ of GDP) in Honduras in 1993?
Offer a very short reply. -0.11. What is the difference between the Amount of CO2 emissions(kg per 2005 US$ of GDP) of Cabo Verde in 1992 and the Amount of CO2 emissions(kg per 2005 US$ of GDP) of Fiji in 1994?
Your answer should be very brief. 0.02. What is the difference between the Amount of CO2 emissions(kg per 2005 US$ of GDP) in Cabo Verde in 1992 and the Amount of CO2 emissions(kg per 2005 US$ of GDP) in Honduras in 1994?
Give a very brief answer. -0.16. What is the difference between the Amount of CO2 emissions(kg per 2005 US$ of GDP) in Fiji in 1992 and the Amount of CO2 emissions(kg per 2005 US$ of GDP) in Honduras in 1994?
Your response must be concise. -0.19. What is the difference between the Amount of CO2 emissions(kg per 2005 US$ of GDP) of Cabo Verde in 1992 and the Amount of CO2 emissions(kg per 2005 US$ of GDP) of Fiji in 1995?
Give a very brief answer. 0. What is the difference between the Amount of CO2 emissions(kg per 2005 US$ of GDP) in Cabo Verde in 1992 and the Amount of CO2 emissions(kg per 2005 US$ of GDP) in Honduras in 1995?
Ensure brevity in your answer.  -0.22. What is the difference between the Amount of CO2 emissions(kg per 2005 US$ of GDP) of Fiji in 1992 and the Amount of CO2 emissions(kg per 2005 US$ of GDP) of Honduras in 1995?
Offer a terse response. -0.25. What is the difference between the Amount of CO2 emissions(kg per 2005 US$ of GDP) of Cabo Verde in 1993 and the Amount of CO2 emissions(kg per 2005 US$ of GDP) of Fiji in 1994?
Keep it short and to the point. -0.01. What is the difference between the Amount of CO2 emissions(kg per 2005 US$ of GDP) in Cabo Verde in 1993 and the Amount of CO2 emissions(kg per 2005 US$ of GDP) in Honduras in 1994?
Make the answer very short. -0.19. What is the difference between the Amount of CO2 emissions(kg per 2005 US$ of GDP) of Fiji in 1993 and the Amount of CO2 emissions(kg per 2005 US$ of GDP) of Honduras in 1994?
Your answer should be compact. -0.18. What is the difference between the Amount of CO2 emissions(kg per 2005 US$ of GDP) of Cabo Verde in 1993 and the Amount of CO2 emissions(kg per 2005 US$ of GDP) of Fiji in 1995?
Your answer should be very brief. -0.03. What is the difference between the Amount of CO2 emissions(kg per 2005 US$ of GDP) in Cabo Verde in 1993 and the Amount of CO2 emissions(kg per 2005 US$ of GDP) in Honduras in 1995?
Your answer should be compact. -0.25. What is the difference between the Amount of CO2 emissions(kg per 2005 US$ of GDP) of Fiji in 1993 and the Amount of CO2 emissions(kg per 2005 US$ of GDP) of Honduras in 1995?
Offer a very short reply. -0.24. What is the difference between the Amount of CO2 emissions(kg per 2005 US$ of GDP) in Cabo Verde in 1994 and the Amount of CO2 emissions(kg per 2005 US$ of GDP) in Fiji in 1995?
Provide a short and direct response. -0.06. What is the difference between the Amount of CO2 emissions(kg per 2005 US$ of GDP) in Cabo Verde in 1994 and the Amount of CO2 emissions(kg per 2005 US$ of GDP) in Honduras in 1995?
Provide a short and direct response. -0.28. What is the difference between the Amount of CO2 emissions(kg per 2005 US$ of GDP) of Fiji in 1994 and the Amount of CO2 emissions(kg per 2005 US$ of GDP) of Honduras in 1995?
Your response must be concise. -0.24. What is the average Amount of CO2 emissions(kg per 2005 US$ of GDP) of Cabo Verde per year?
Ensure brevity in your answer.  0.33. What is the average Amount of CO2 emissions(kg per 2005 US$ of GDP) in Fiji per year?
Offer a terse response. 0.34. What is the average Amount of CO2 emissions(kg per 2005 US$ of GDP) of Honduras per year?
Keep it short and to the point. 0.49. In the year 1988, what is the difference between the Amount of CO2 emissions(kg per 2005 US$ of GDP) in Cabo Verde and Amount of CO2 emissions(kg per 2005 US$ of GDP) in Fiji?
Offer a terse response. 0.01. In the year 1988, what is the difference between the Amount of CO2 emissions(kg per 2005 US$ of GDP) of Cabo Verde and Amount of CO2 emissions(kg per 2005 US$ of GDP) of Honduras?
Ensure brevity in your answer.  -0.16. In the year 1988, what is the difference between the Amount of CO2 emissions(kg per 2005 US$ of GDP) of Fiji and Amount of CO2 emissions(kg per 2005 US$ of GDP) of Honduras?
Offer a very short reply. -0.17. In the year 1989, what is the difference between the Amount of CO2 emissions(kg per 2005 US$ of GDP) of Cabo Verde and Amount of CO2 emissions(kg per 2005 US$ of GDP) of Fiji?
Keep it short and to the point. 0.01. In the year 1989, what is the difference between the Amount of CO2 emissions(kg per 2005 US$ of GDP) in Cabo Verde and Amount of CO2 emissions(kg per 2005 US$ of GDP) in Honduras?
Provide a short and direct response. -0.16. In the year 1989, what is the difference between the Amount of CO2 emissions(kg per 2005 US$ of GDP) in Fiji and Amount of CO2 emissions(kg per 2005 US$ of GDP) in Honduras?
Your answer should be very brief. -0.17. In the year 1990, what is the difference between the Amount of CO2 emissions(kg per 2005 US$ of GDP) in Cabo Verde and Amount of CO2 emissions(kg per 2005 US$ of GDP) in Fiji?
Keep it short and to the point. -0.03. In the year 1990, what is the difference between the Amount of CO2 emissions(kg per 2005 US$ of GDP) of Cabo Verde and Amount of CO2 emissions(kg per 2005 US$ of GDP) of Honduras?
Make the answer very short. -0.11. In the year 1990, what is the difference between the Amount of CO2 emissions(kg per 2005 US$ of GDP) of Fiji and Amount of CO2 emissions(kg per 2005 US$ of GDP) of Honduras?
Your response must be concise. -0.08. In the year 1991, what is the difference between the Amount of CO2 emissions(kg per 2005 US$ of GDP) in Cabo Verde and Amount of CO2 emissions(kg per 2005 US$ of GDP) in Fiji?
Your answer should be compact. 0.03. In the year 1991, what is the difference between the Amount of CO2 emissions(kg per 2005 US$ of GDP) of Cabo Verde and Amount of CO2 emissions(kg per 2005 US$ of GDP) of Honduras?
Give a very brief answer. -0.11. In the year 1991, what is the difference between the Amount of CO2 emissions(kg per 2005 US$ of GDP) in Fiji and Amount of CO2 emissions(kg per 2005 US$ of GDP) in Honduras?
Give a very brief answer. -0.14. In the year 1992, what is the difference between the Amount of CO2 emissions(kg per 2005 US$ of GDP) of Cabo Verde and Amount of CO2 emissions(kg per 2005 US$ of GDP) of Fiji?
Your response must be concise. 0.03. In the year 1992, what is the difference between the Amount of CO2 emissions(kg per 2005 US$ of GDP) of Cabo Verde and Amount of CO2 emissions(kg per 2005 US$ of GDP) of Honduras?
Offer a terse response. -0.14. In the year 1992, what is the difference between the Amount of CO2 emissions(kg per 2005 US$ of GDP) of Fiji and Amount of CO2 emissions(kg per 2005 US$ of GDP) of Honduras?
Keep it short and to the point. -0.17. In the year 1993, what is the difference between the Amount of CO2 emissions(kg per 2005 US$ of GDP) in Cabo Verde and Amount of CO2 emissions(kg per 2005 US$ of GDP) in Fiji?
Your answer should be very brief. -0.01. In the year 1993, what is the difference between the Amount of CO2 emissions(kg per 2005 US$ of GDP) of Cabo Verde and Amount of CO2 emissions(kg per 2005 US$ of GDP) of Honduras?
Your answer should be very brief. -0.1. In the year 1993, what is the difference between the Amount of CO2 emissions(kg per 2005 US$ of GDP) in Fiji and Amount of CO2 emissions(kg per 2005 US$ of GDP) in Honduras?
Your response must be concise. -0.1. In the year 1994, what is the difference between the Amount of CO2 emissions(kg per 2005 US$ of GDP) of Cabo Verde and Amount of CO2 emissions(kg per 2005 US$ of GDP) of Fiji?
Provide a succinct answer. -0.05. In the year 1994, what is the difference between the Amount of CO2 emissions(kg per 2005 US$ of GDP) in Cabo Verde and Amount of CO2 emissions(kg per 2005 US$ of GDP) in Honduras?
Give a very brief answer. -0.22. In the year 1994, what is the difference between the Amount of CO2 emissions(kg per 2005 US$ of GDP) in Fiji and Amount of CO2 emissions(kg per 2005 US$ of GDP) in Honduras?
Offer a terse response. -0.17. In the year 1995, what is the difference between the Amount of CO2 emissions(kg per 2005 US$ of GDP) in Cabo Verde and Amount of CO2 emissions(kg per 2005 US$ of GDP) in Fiji?
Offer a very short reply. -0.09. In the year 1995, what is the difference between the Amount of CO2 emissions(kg per 2005 US$ of GDP) of Cabo Verde and Amount of CO2 emissions(kg per 2005 US$ of GDP) of Honduras?
Make the answer very short. -0.31. In the year 1995, what is the difference between the Amount of CO2 emissions(kg per 2005 US$ of GDP) in Fiji and Amount of CO2 emissions(kg per 2005 US$ of GDP) in Honduras?
Ensure brevity in your answer.  -0.22. What is the ratio of the Amount of CO2 emissions(kg per 2005 US$ of GDP) in Cabo Verde in 1988 to that in 1989?
Offer a very short reply. 0.96. What is the ratio of the Amount of CO2 emissions(kg per 2005 US$ of GDP) of Fiji in 1988 to that in 1989?
Your answer should be compact. 0.94. What is the ratio of the Amount of CO2 emissions(kg per 2005 US$ of GDP) in Honduras in 1988 to that in 1989?
Your answer should be very brief. 0.96. What is the ratio of the Amount of CO2 emissions(kg per 2005 US$ of GDP) in Cabo Verde in 1988 to that in 1990?
Give a very brief answer. 0.89. What is the ratio of the Amount of CO2 emissions(kg per 2005 US$ of GDP) of Fiji in 1988 to that in 1990?
Provide a short and direct response. 0.77. What is the ratio of the Amount of CO2 emissions(kg per 2005 US$ of GDP) in Honduras in 1988 to that in 1990?
Provide a short and direct response. 1.01. What is the ratio of the Amount of CO2 emissions(kg per 2005 US$ of GDP) of Cabo Verde in 1988 to that in 1991?
Your answer should be compact. 0.86. What is the ratio of the Amount of CO2 emissions(kg per 2005 US$ of GDP) of Fiji in 1988 to that in 1991?
Ensure brevity in your answer.  0.91. What is the ratio of the Amount of CO2 emissions(kg per 2005 US$ of GDP) of Honduras in 1988 to that in 1991?
Make the answer very short. 1. What is the ratio of the Amount of CO2 emissions(kg per 2005 US$ of GDP) in Cabo Verde in 1988 to that in 1992?
Your response must be concise. 0.86. What is the ratio of the Amount of CO2 emissions(kg per 2005 US$ of GDP) of Fiji in 1988 to that in 1992?
Ensure brevity in your answer.  0.9. What is the ratio of the Amount of CO2 emissions(kg per 2005 US$ of GDP) in Honduras in 1988 to that in 1992?
Your answer should be very brief. 0.93. What is the ratio of the Amount of CO2 emissions(kg per 2005 US$ of GDP) of Cabo Verde in 1988 to that in 1993?
Provide a short and direct response. 0.93. What is the ratio of the Amount of CO2 emissions(kg per 2005 US$ of GDP) in Fiji in 1988 to that in 1993?
Give a very brief answer. 0.87. What is the ratio of the Amount of CO2 emissions(kg per 2005 US$ of GDP) in Honduras in 1988 to that in 1993?
Offer a terse response. 1.06. What is the ratio of the Amount of CO2 emissions(kg per 2005 US$ of GDP) in Cabo Verde in 1988 to that in 1994?
Your answer should be compact. 1.03. What is the ratio of the Amount of CO2 emissions(kg per 2005 US$ of GDP) of Fiji in 1988 to that in 1994?
Keep it short and to the point. 0.85. What is the ratio of the Amount of CO2 emissions(kg per 2005 US$ of GDP) of Honduras in 1988 to that in 1994?
Ensure brevity in your answer.  0.9. What is the ratio of the Amount of CO2 emissions(kg per 2005 US$ of GDP) of Cabo Verde in 1988 to that in 1995?
Provide a short and direct response. 1.14. What is the ratio of the Amount of CO2 emissions(kg per 2005 US$ of GDP) in Fiji in 1988 to that in 1995?
Provide a succinct answer. 0.82. What is the ratio of the Amount of CO2 emissions(kg per 2005 US$ of GDP) in Honduras in 1988 to that in 1995?
Make the answer very short. 0.8. What is the ratio of the Amount of CO2 emissions(kg per 2005 US$ of GDP) of Cabo Verde in 1989 to that in 1990?
Your answer should be compact. 0.92. What is the ratio of the Amount of CO2 emissions(kg per 2005 US$ of GDP) in Fiji in 1989 to that in 1990?
Give a very brief answer. 0.82. What is the ratio of the Amount of CO2 emissions(kg per 2005 US$ of GDP) in Honduras in 1989 to that in 1990?
Your response must be concise. 1.05. What is the ratio of the Amount of CO2 emissions(kg per 2005 US$ of GDP) of Cabo Verde in 1989 to that in 1991?
Provide a succinct answer. 0.9. What is the ratio of the Amount of CO2 emissions(kg per 2005 US$ of GDP) of Fiji in 1989 to that in 1991?
Provide a short and direct response. 0.96. What is the ratio of the Amount of CO2 emissions(kg per 2005 US$ of GDP) in Honduras in 1989 to that in 1991?
Provide a succinct answer. 1.04. What is the ratio of the Amount of CO2 emissions(kg per 2005 US$ of GDP) in Cabo Verde in 1989 to that in 1992?
Ensure brevity in your answer.  0.89. What is the ratio of the Amount of CO2 emissions(kg per 2005 US$ of GDP) of Fiji in 1989 to that in 1992?
Ensure brevity in your answer.  0.95. What is the ratio of the Amount of CO2 emissions(kg per 2005 US$ of GDP) in Honduras in 1989 to that in 1992?
Offer a terse response. 0.97. What is the ratio of the Amount of CO2 emissions(kg per 2005 US$ of GDP) of Cabo Verde in 1989 to that in 1993?
Provide a succinct answer. 0.97. What is the ratio of the Amount of CO2 emissions(kg per 2005 US$ of GDP) of Fiji in 1989 to that in 1993?
Provide a succinct answer. 0.92. What is the ratio of the Amount of CO2 emissions(kg per 2005 US$ of GDP) of Honduras in 1989 to that in 1993?
Ensure brevity in your answer.  1.11. What is the ratio of the Amount of CO2 emissions(kg per 2005 US$ of GDP) in Cabo Verde in 1989 to that in 1994?
Offer a very short reply. 1.08. What is the ratio of the Amount of CO2 emissions(kg per 2005 US$ of GDP) in Fiji in 1989 to that in 1994?
Offer a terse response. 0.9. What is the ratio of the Amount of CO2 emissions(kg per 2005 US$ of GDP) of Honduras in 1989 to that in 1994?
Your answer should be very brief. 0.94. What is the ratio of the Amount of CO2 emissions(kg per 2005 US$ of GDP) of Cabo Verde in 1989 to that in 1995?
Give a very brief answer. 1.19. What is the ratio of the Amount of CO2 emissions(kg per 2005 US$ of GDP) in Fiji in 1989 to that in 1995?
Offer a terse response. 0.87. What is the ratio of the Amount of CO2 emissions(kg per 2005 US$ of GDP) of Honduras in 1989 to that in 1995?
Offer a terse response. 0.84. What is the ratio of the Amount of CO2 emissions(kg per 2005 US$ of GDP) of Cabo Verde in 1990 to that in 1991?
Your answer should be very brief. 0.97. What is the ratio of the Amount of CO2 emissions(kg per 2005 US$ of GDP) of Fiji in 1990 to that in 1991?
Give a very brief answer. 1.18. What is the ratio of the Amount of CO2 emissions(kg per 2005 US$ of GDP) in Cabo Verde in 1990 to that in 1992?
Keep it short and to the point. 0.96. What is the ratio of the Amount of CO2 emissions(kg per 2005 US$ of GDP) in Fiji in 1990 to that in 1992?
Your response must be concise. 1.17. What is the ratio of the Amount of CO2 emissions(kg per 2005 US$ of GDP) in Honduras in 1990 to that in 1992?
Your answer should be compact. 0.92. What is the ratio of the Amount of CO2 emissions(kg per 2005 US$ of GDP) of Cabo Verde in 1990 to that in 1993?
Provide a short and direct response. 1.05. What is the ratio of the Amount of CO2 emissions(kg per 2005 US$ of GDP) of Fiji in 1990 to that in 1993?
Your answer should be compact. 1.13. What is the ratio of the Amount of CO2 emissions(kg per 2005 US$ of GDP) in Honduras in 1990 to that in 1993?
Give a very brief answer. 1.05. What is the ratio of the Amount of CO2 emissions(kg per 2005 US$ of GDP) in Cabo Verde in 1990 to that in 1994?
Your response must be concise. 1.17. What is the ratio of the Amount of CO2 emissions(kg per 2005 US$ of GDP) of Fiji in 1990 to that in 1994?
Your answer should be very brief. 1.11. What is the ratio of the Amount of CO2 emissions(kg per 2005 US$ of GDP) in Honduras in 1990 to that in 1994?
Give a very brief answer. 0.89. What is the ratio of the Amount of CO2 emissions(kg per 2005 US$ of GDP) of Cabo Verde in 1990 to that in 1995?
Your answer should be compact. 1.29. What is the ratio of the Amount of CO2 emissions(kg per 2005 US$ of GDP) of Fiji in 1990 to that in 1995?
Your response must be concise. 1.07. What is the ratio of the Amount of CO2 emissions(kg per 2005 US$ of GDP) in Honduras in 1990 to that in 1995?
Your response must be concise. 0.8. What is the ratio of the Amount of CO2 emissions(kg per 2005 US$ of GDP) of Honduras in 1991 to that in 1992?
Your response must be concise. 0.93. What is the ratio of the Amount of CO2 emissions(kg per 2005 US$ of GDP) in Cabo Verde in 1991 to that in 1993?
Your answer should be very brief. 1.08. What is the ratio of the Amount of CO2 emissions(kg per 2005 US$ of GDP) in Fiji in 1991 to that in 1993?
Your answer should be very brief. 0.96. What is the ratio of the Amount of CO2 emissions(kg per 2005 US$ of GDP) of Honduras in 1991 to that in 1993?
Offer a very short reply. 1.06. What is the ratio of the Amount of CO2 emissions(kg per 2005 US$ of GDP) in Cabo Verde in 1991 to that in 1994?
Offer a terse response. 1.2. What is the ratio of the Amount of CO2 emissions(kg per 2005 US$ of GDP) of Fiji in 1991 to that in 1994?
Give a very brief answer. 0.94. What is the ratio of the Amount of CO2 emissions(kg per 2005 US$ of GDP) of Honduras in 1991 to that in 1994?
Ensure brevity in your answer.  0.9. What is the ratio of the Amount of CO2 emissions(kg per 2005 US$ of GDP) in Cabo Verde in 1991 to that in 1995?
Ensure brevity in your answer.  1.32. What is the ratio of the Amount of CO2 emissions(kg per 2005 US$ of GDP) in Fiji in 1991 to that in 1995?
Keep it short and to the point. 0.91. What is the ratio of the Amount of CO2 emissions(kg per 2005 US$ of GDP) of Honduras in 1991 to that in 1995?
Ensure brevity in your answer.  0.8. What is the ratio of the Amount of CO2 emissions(kg per 2005 US$ of GDP) in Cabo Verde in 1992 to that in 1993?
Offer a very short reply. 1.09. What is the ratio of the Amount of CO2 emissions(kg per 2005 US$ of GDP) of Fiji in 1992 to that in 1993?
Give a very brief answer. 0.97. What is the ratio of the Amount of CO2 emissions(kg per 2005 US$ of GDP) of Honduras in 1992 to that in 1993?
Ensure brevity in your answer.  1.15. What is the ratio of the Amount of CO2 emissions(kg per 2005 US$ of GDP) of Cabo Verde in 1992 to that in 1994?
Give a very brief answer. 1.21. What is the ratio of the Amount of CO2 emissions(kg per 2005 US$ of GDP) in Fiji in 1992 to that in 1994?
Provide a succinct answer. 0.95. What is the ratio of the Amount of CO2 emissions(kg per 2005 US$ of GDP) in Honduras in 1992 to that in 1994?
Provide a succinct answer. 0.97. What is the ratio of the Amount of CO2 emissions(kg per 2005 US$ of GDP) in Cabo Verde in 1992 to that in 1995?
Your answer should be compact. 1.34. What is the ratio of the Amount of CO2 emissions(kg per 2005 US$ of GDP) of Fiji in 1992 to that in 1995?
Give a very brief answer. 0.91. What is the ratio of the Amount of CO2 emissions(kg per 2005 US$ of GDP) of Honduras in 1992 to that in 1995?
Ensure brevity in your answer.  0.87. What is the ratio of the Amount of CO2 emissions(kg per 2005 US$ of GDP) in Cabo Verde in 1993 to that in 1994?
Your response must be concise. 1.11. What is the ratio of the Amount of CO2 emissions(kg per 2005 US$ of GDP) in Fiji in 1993 to that in 1994?
Provide a short and direct response. 0.98. What is the ratio of the Amount of CO2 emissions(kg per 2005 US$ of GDP) in Honduras in 1993 to that in 1994?
Keep it short and to the point. 0.84. What is the ratio of the Amount of CO2 emissions(kg per 2005 US$ of GDP) in Cabo Verde in 1993 to that in 1995?
Provide a short and direct response. 1.23. What is the ratio of the Amount of CO2 emissions(kg per 2005 US$ of GDP) of Fiji in 1993 to that in 1995?
Make the answer very short. 0.95. What is the ratio of the Amount of CO2 emissions(kg per 2005 US$ of GDP) in Honduras in 1993 to that in 1995?
Keep it short and to the point. 0.75. What is the ratio of the Amount of CO2 emissions(kg per 2005 US$ of GDP) of Cabo Verde in 1994 to that in 1995?
Keep it short and to the point. 1.11. What is the ratio of the Amount of CO2 emissions(kg per 2005 US$ of GDP) of Fiji in 1994 to that in 1995?
Provide a short and direct response. 0.96. What is the ratio of the Amount of CO2 emissions(kg per 2005 US$ of GDP) in Honduras in 1994 to that in 1995?
Your answer should be very brief. 0.9. What is the difference between the highest and the second highest Amount of CO2 emissions(kg per 2005 US$ of GDP) in Cabo Verde?
Make the answer very short. 0. What is the difference between the highest and the second highest Amount of CO2 emissions(kg per 2005 US$ of GDP) in Fiji?
Provide a succinct answer. 0.02. What is the difference between the highest and the second highest Amount of CO2 emissions(kg per 2005 US$ of GDP) of Honduras?
Your response must be concise. 0.06. What is the difference between the highest and the lowest Amount of CO2 emissions(kg per 2005 US$ of GDP) in Cabo Verde?
Ensure brevity in your answer.  0.09. What is the difference between the highest and the lowest Amount of CO2 emissions(kg per 2005 US$ of GDP) of Fiji?
Provide a short and direct response. 0.09. What is the difference between the highest and the lowest Amount of CO2 emissions(kg per 2005 US$ of GDP) in Honduras?
Your answer should be compact. 0.14. 